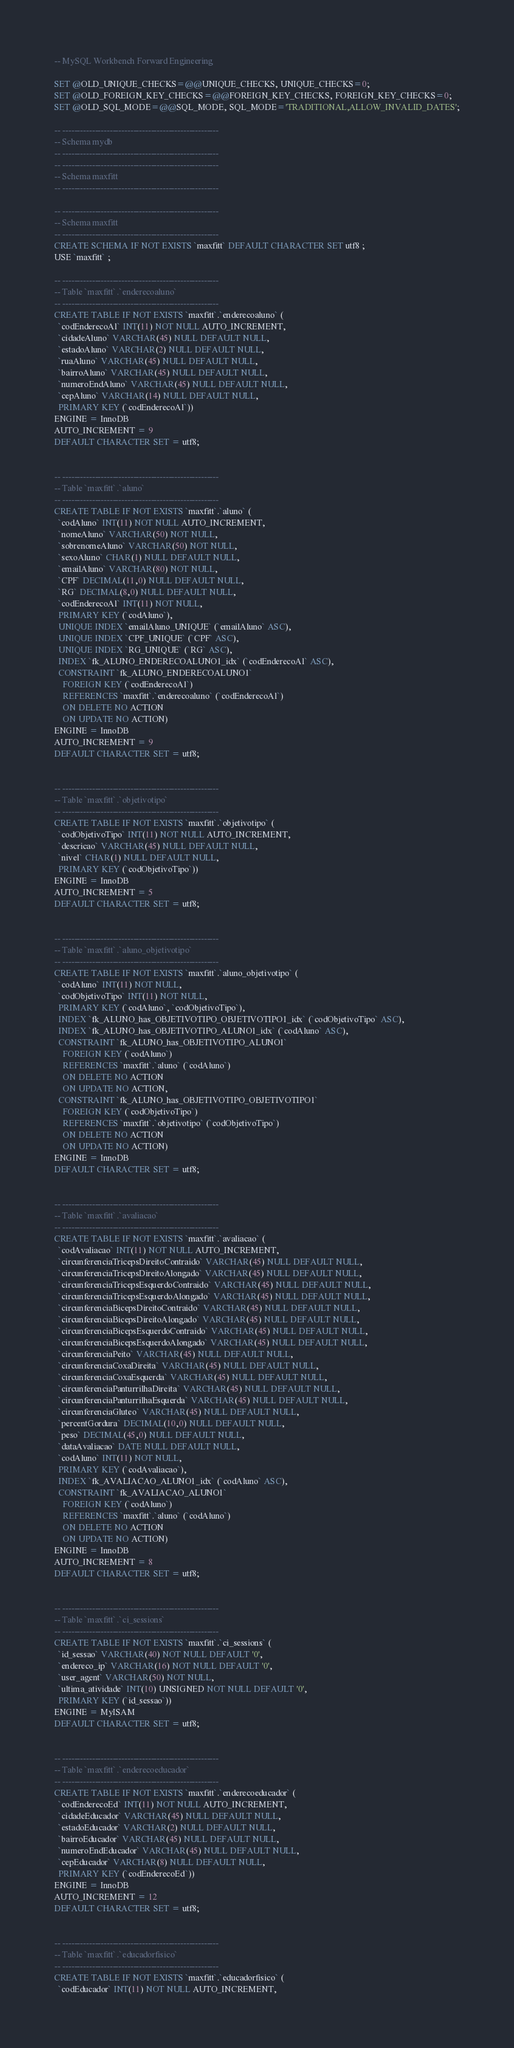<code> <loc_0><loc_0><loc_500><loc_500><_SQL_>-- MySQL Workbench Forward Engineering

SET @OLD_UNIQUE_CHECKS=@@UNIQUE_CHECKS, UNIQUE_CHECKS=0;
SET @OLD_FOREIGN_KEY_CHECKS=@@FOREIGN_KEY_CHECKS, FOREIGN_KEY_CHECKS=0;
SET @OLD_SQL_MODE=@@SQL_MODE, SQL_MODE='TRADITIONAL,ALLOW_INVALID_DATES';

-- -----------------------------------------------------
-- Schema mydb
-- -----------------------------------------------------
-- -----------------------------------------------------
-- Schema maxfitt
-- -----------------------------------------------------

-- -----------------------------------------------------
-- Schema maxfitt
-- -----------------------------------------------------
CREATE SCHEMA IF NOT EXISTS `maxfitt` DEFAULT CHARACTER SET utf8 ;
USE `maxfitt` ;

-- -----------------------------------------------------
-- Table `maxfitt`.`enderecoaluno`
-- -----------------------------------------------------
CREATE TABLE IF NOT EXISTS `maxfitt`.`enderecoaluno` (
  `codEnderecoAl` INT(11) NOT NULL AUTO_INCREMENT,
  `cidadeAluno` VARCHAR(45) NULL DEFAULT NULL,
  `estadoAluno` VARCHAR(2) NULL DEFAULT NULL,
  `ruaAluno` VARCHAR(45) NULL DEFAULT NULL,
  `bairroAluno` VARCHAR(45) NULL DEFAULT NULL,
  `numeroEndAluno` VARCHAR(45) NULL DEFAULT NULL,
  `cepAluno` VARCHAR(14) NULL DEFAULT NULL,
  PRIMARY KEY (`codEnderecoAl`))
ENGINE = InnoDB
AUTO_INCREMENT = 9
DEFAULT CHARACTER SET = utf8;


-- -----------------------------------------------------
-- Table `maxfitt`.`aluno`
-- -----------------------------------------------------
CREATE TABLE IF NOT EXISTS `maxfitt`.`aluno` (
  `codAluno` INT(11) NOT NULL AUTO_INCREMENT,
  `nomeAluno` VARCHAR(50) NOT NULL,
  `sobrenomeAluno` VARCHAR(50) NOT NULL,
  `sexoAluno` CHAR(1) NULL DEFAULT NULL,
  `emailAluno` VARCHAR(80) NOT NULL,
  `CPF` DECIMAL(11,0) NULL DEFAULT NULL,
  `RG` DECIMAL(8,0) NULL DEFAULT NULL,
  `codEnderecoAl` INT(11) NOT NULL,
  PRIMARY KEY (`codAluno`),
  UNIQUE INDEX `emailAluno_UNIQUE` (`emailAluno` ASC),
  UNIQUE INDEX `CPF_UNIQUE` (`CPF` ASC),
  UNIQUE INDEX `RG_UNIQUE` (`RG` ASC),
  INDEX `fk_ALUNO_ENDERECOALUNO1_idx` (`codEnderecoAl` ASC),
  CONSTRAINT `fk_ALUNO_ENDERECOALUNO1`
    FOREIGN KEY (`codEnderecoAl`)
    REFERENCES `maxfitt`.`enderecoaluno` (`codEnderecoAl`)
    ON DELETE NO ACTION
    ON UPDATE NO ACTION)
ENGINE = InnoDB
AUTO_INCREMENT = 9
DEFAULT CHARACTER SET = utf8;


-- -----------------------------------------------------
-- Table `maxfitt`.`objetivotipo`
-- -----------------------------------------------------
CREATE TABLE IF NOT EXISTS `maxfitt`.`objetivotipo` (
  `codObjetivoTipo` INT(11) NOT NULL AUTO_INCREMENT,
  `descricao` VARCHAR(45) NULL DEFAULT NULL,
  `nivel` CHAR(1) NULL DEFAULT NULL,
  PRIMARY KEY (`codObjetivoTipo`))
ENGINE = InnoDB
AUTO_INCREMENT = 5
DEFAULT CHARACTER SET = utf8;


-- -----------------------------------------------------
-- Table `maxfitt`.`aluno_objetivotipo`
-- -----------------------------------------------------
CREATE TABLE IF NOT EXISTS `maxfitt`.`aluno_objetivotipo` (
  `codAluno` INT(11) NOT NULL,
  `codObjetivoTipo` INT(11) NOT NULL,
  PRIMARY KEY (`codAluno`, `codObjetivoTipo`),
  INDEX `fk_ALUNO_has_OBJETIVOTIPO_OBJETIVOTIPO1_idx` (`codObjetivoTipo` ASC),
  INDEX `fk_ALUNO_has_OBJETIVOTIPO_ALUNO1_idx` (`codAluno` ASC),
  CONSTRAINT `fk_ALUNO_has_OBJETIVOTIPO_ALUNO1`
    FOREIGN KEY (`codAluno`)
    REFERENCES `maxfitt`.`aluno` (`codAluno`)
    ON DELETE NO ACTION
    ON UPDATE NO ACTION,
  CONSTRAINT `fk_ALUNO_has_OBJETIVOTIPO_OBJETIVOTIPO1`
    FOREIGN KEY (`codObjetivoTipo`)
    REFERENCES `maxfitt`.`objetivotipo` (`codObjetivoTipo`)
    ON DELETE NO ACTION
    ON UPDATE NO ACTION)
ENGINE = InnoDB
DEFAULT CHARACTER SET = utf8;


-- -----------------------------------------------------
-- Table `maxfitt`.`avaliacao`
-- -----------------------------------------------------
CREATE TABLE IF NOT EXISTS `maxfitt`.`avaliacao` (
  `codAvaliacao` INT(11) NOT NULL AUTO_INCREMENT,
  `circunferenciaTricepsDireitoContraido` VARCHAR(45) NULL DEFAULT NULL,
  `circunferenciaTricepsDireitoAlongado` VARCHAR(45) NULL DEFAULT NULL,
  `circunferenciaTricepsEsquerdoContraido` VARCHAR(45) NULL DEFAULT NULL,
  `circunferenciaTricepsEsquerdoAlongado` VARCHAR(45) NULL DEFAULT NULL,
  `circunferenciaBicepsDireitoContraido` VARCHAR(45) NULL DEFAULT NULL,
  `circunferenciaBicepsDireitoAlongado` VARCHAR(45) NULL DEFAULT NULL,
  `circunferenciaBicepsEsquerdoContraido` VARCHAR(45) NULL DEFAULT NULL,
  `circunferenciaBicepsEsquerdoAlongado` VARCHAR(45) NULL DEFAULT NULL,
  `circunferenciaPeito` VARCHAR(45) NULL DEFAULT NULL,
  `circunferenciaCoxaDireita` VARCHAR(45) NULL DEFAULT NULL,
  `circunferenciaCoxaEsquerda` VARCHAR(45) NULL DEFAULT NULL,
  `circunferenciaPanturrilhaDireita` VARCHAR(45) NULL DEFAULT NULL,
  `circunferenciaPanturrilhaEsquerda` VARCHAR(45) NULL DEFAULT NULL,
  `circunferenciaGluteo` VARCHAR(45) NULL DEFAULT NULL,
  `percentGordura` DECIMAL(10,0) NULL DEFAULT NULL,
  `peso` DECIMAL(45,0) NULL DEFAULT NULL,
  `dataAvaliacao` DATE NULL DEFAULT NULL,
  `codAluno` INT(11) NOT NULL,
  PRIMARY KEY (`codAvaliacao`),
  INDEX `fk_AVALIACAO_ALUNO1_idx` (`codAluno` ASC),
  CONSTRAINT `fk_AVALIACAO_ALUNO1`
    FOREIGN KEY (`codAluno`)
    REFERENCES `maxfitt`.`aluno` (`codAluno`)
    ON DELETE NO ACTION
    ON UPDATE NO ACTION)
ENGINE = InnoDB
AUTO_INCREMENT = 8
DEFAULT CHARACTER SET = utf8;


-- -----------------------------------------------------
-- Table `maxfitt`.`ci_sessions`
-- -----------------------------------------------------
CREATE TABLE IF NOT EXISTS `maxfitt`.`ci_sessions` (
  `id_sessao` VARCHAR(40) NOT NULL DEFAULT '0',
  `endereco_ip` VARCHAR(16) NOT NULL DEFAULT '0',
  `user_agent` VARCHAR(50) NOT NULL,
  `ultima_atividade` INT(10) UNSIGNED NOT NULL DEFAULT '0',
  PRIMARY KEY (`id_sessao`))
ENGINE = MyISAM
DEFAULT CHARACTER SET = utf8;


-- -----------------------------------------------------
-- Table `maxfitt`.`enderecoeducador`
-- -----------------------------------------------------
CREATE TABLE IF NOT EXISTS `maxfitt`.`enderecoeducador` (
  `codEnderecoEd` INT(11) NOT NULL AUTO_INCREMENT,
  `cidadeEducador` VARCHAR(45) NULL DEFAULT NULL,
  `estadoEducador` VARCHAR(2) NULL DEFAULT NULL,
  `bairroEducador` VARCHAR(45) NULL DEFAULT NULL,
  `numeroEndEducador` VARCHAR(45) NULL DEFAULT NULL,
  `cepEducador` VARCHAR(8) NULL DEFAULT NULL,
  PRIMARY KEY (`codEnderecoEd`))
ENGINE = InnoDB
AUTO_INCREMENT = 12
DEFAULT CHARACTER SET = utf8;


-- -----------------------------------------------------
-- Table `maxfitt`.`educadorfisico`
-- -----------------------------------------------------
CREATE TABLE IF NOT EXISTS `maxfitt`.`educadorfisico` (
  `codEducador` INT(11) NOT NULL AUTO_INCREMENT,</code> 